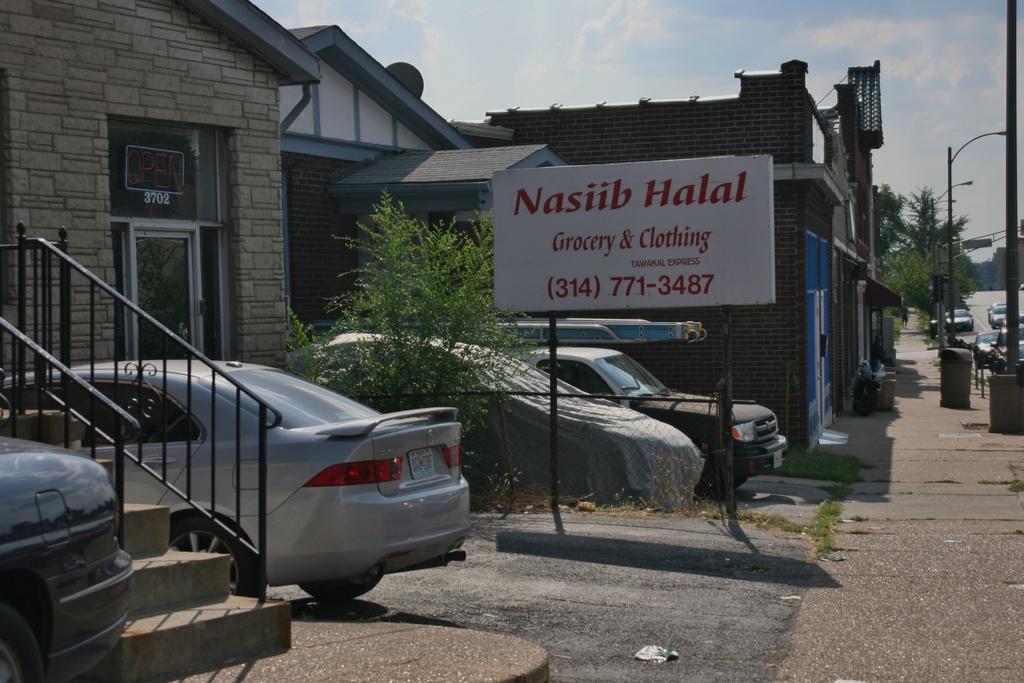Could you give a brief overview of what you see in this image? In the image I can see a place where we have some houses, trees, poles, cars and a board to the side. 